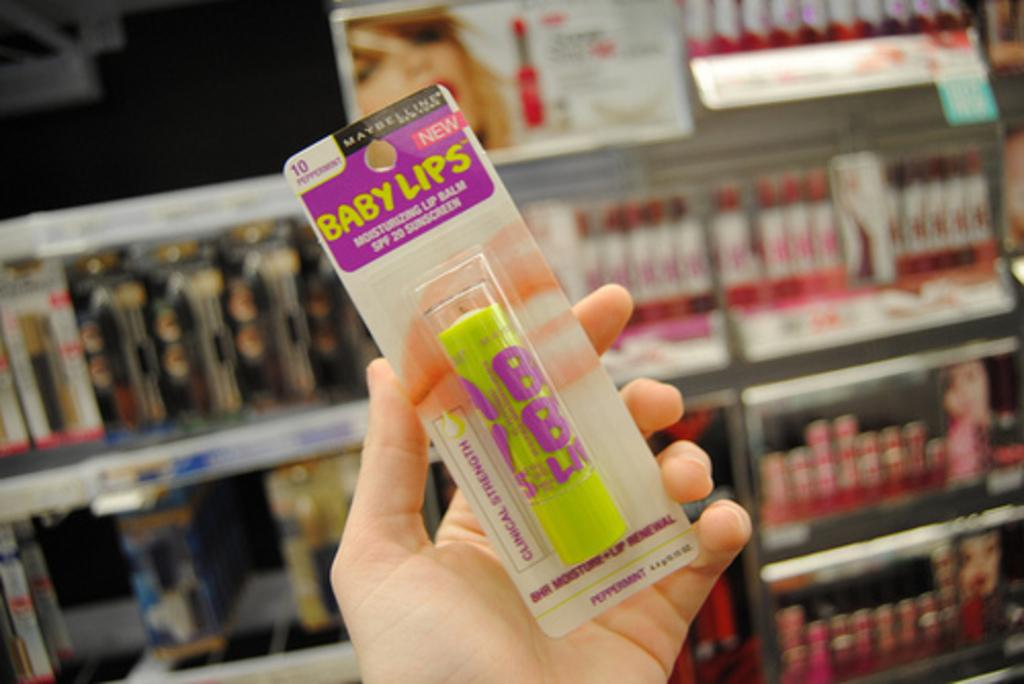What is the human hand holding in the image? The human hand is holding an object in the image, but the specific object cannot be determined from the provided facts. What can be seen in the background of the image? There are objects kept in racks in the background of the image. What type of roof can be seen on the engine in the image? There is no engine or roof present in the image. What is the zinc content of the object being held by the human hand in the image? The zinc content of the object being held by the human hand cannot be determined from the provided facts. 